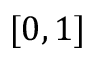Convert formula to latex. <formula><loc_0><loc_0><loc_500><loc_500>[ 0 , 1 ]</formula> 